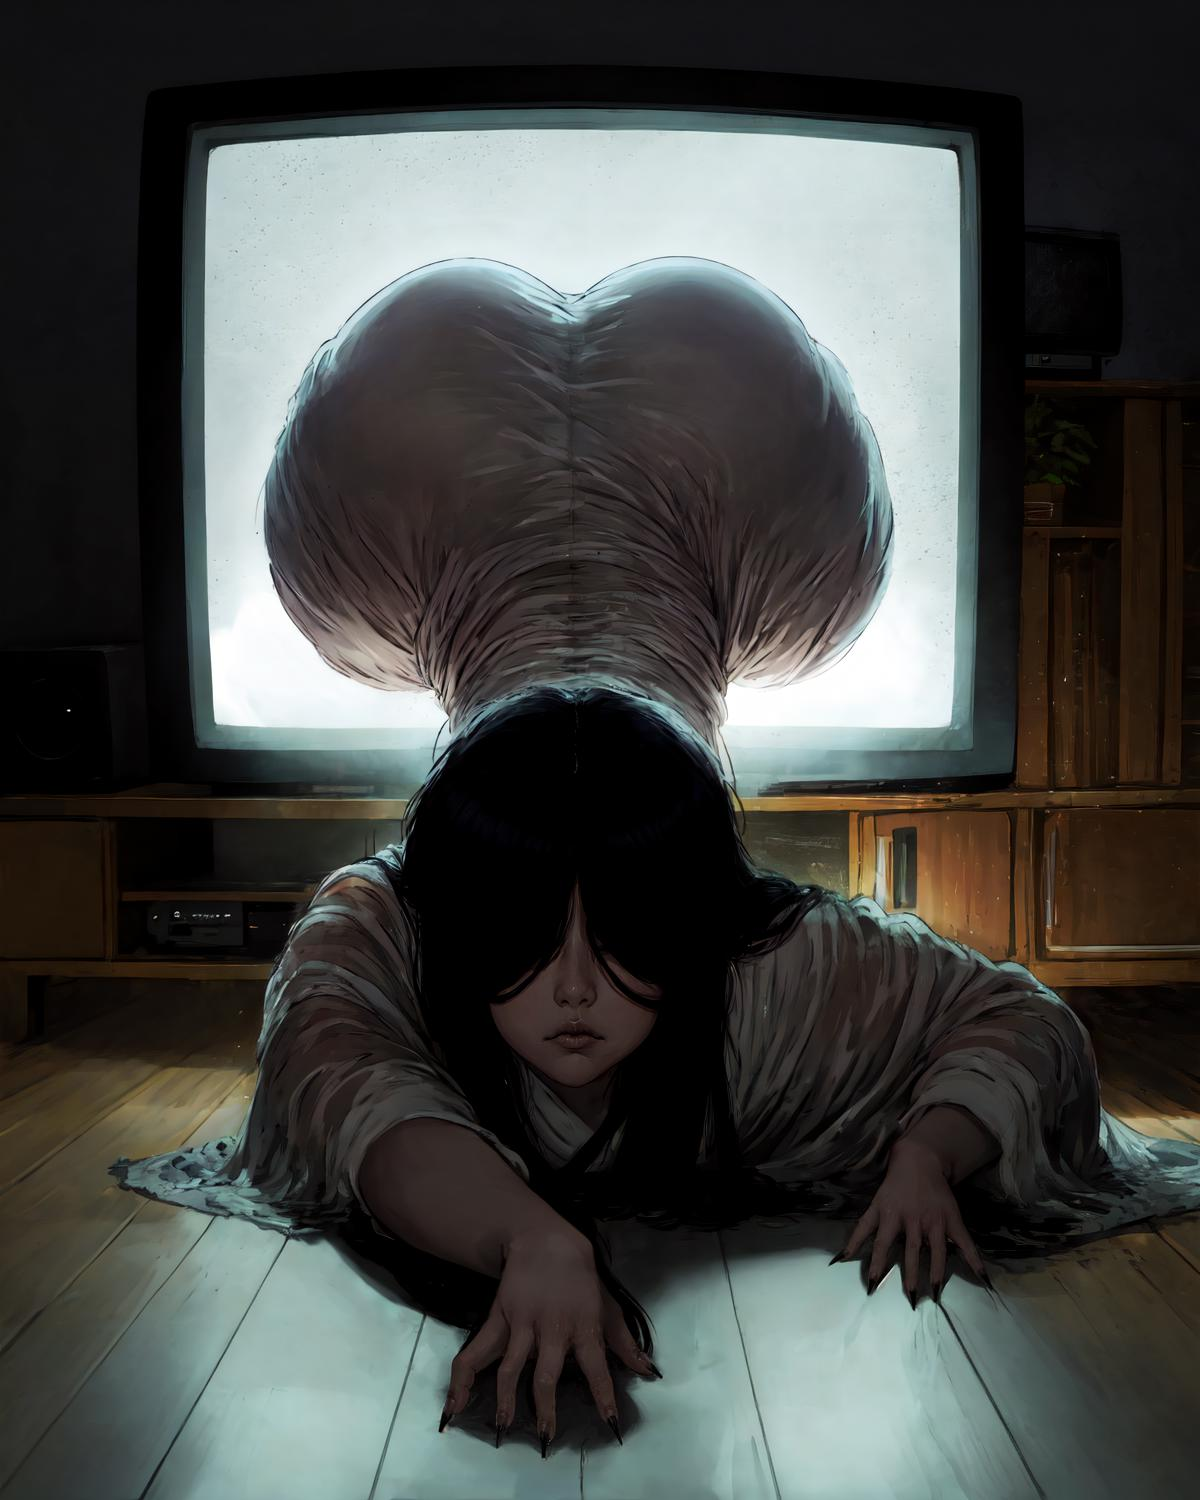describe this image
 The image depicts a female figure sitting on the floor, with long dark hair obscuring her face. She appears to be in a dimly lit room, with a large rectangular screen or monitor behind her emitting a bright, ethereal glow. The figure has a pensive, almost melancholic expression, and seems to be deeply absorbed in her own thoughts or feelings. The overall atmosphere of the image is one of introspection and a sense of being lost or disconnected from one's surroundings. 